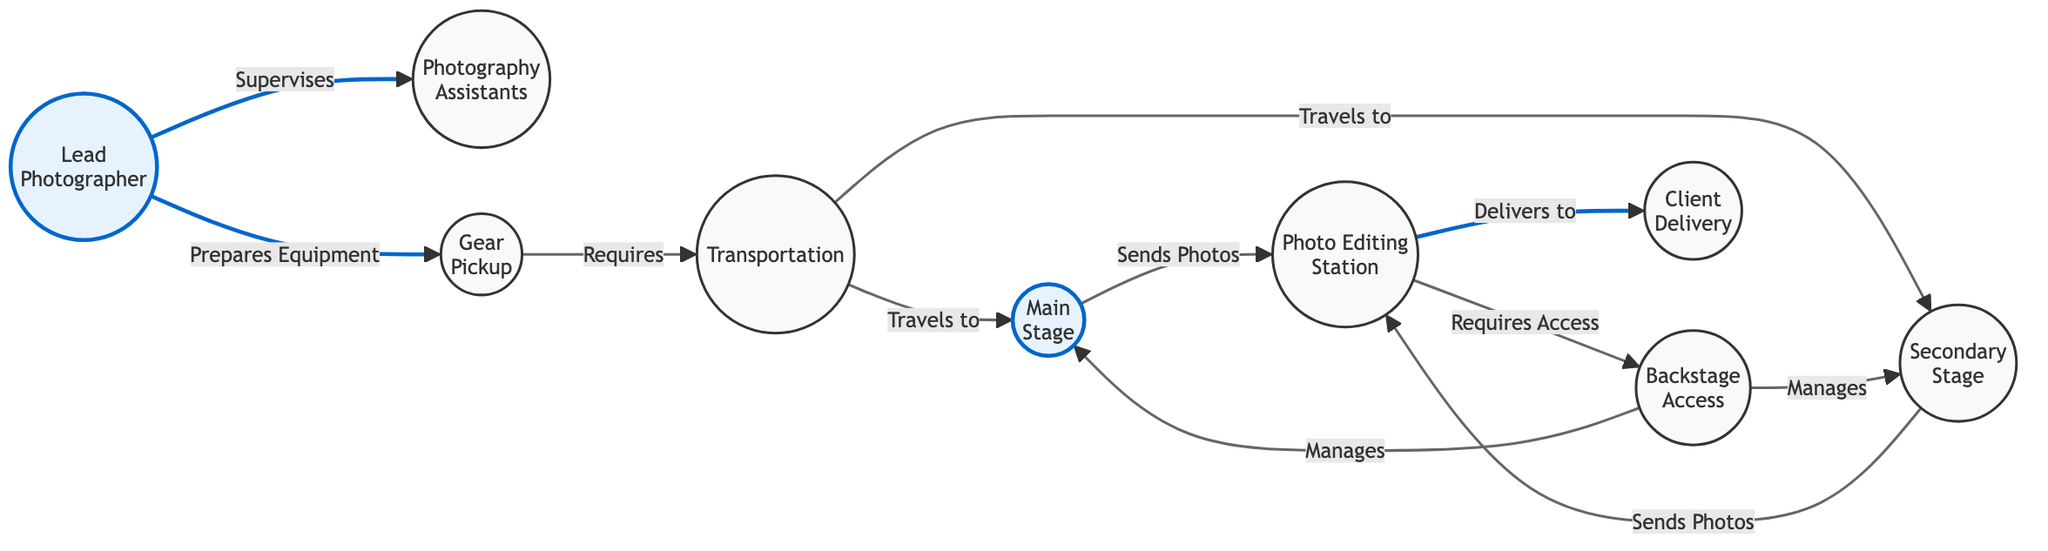What is the relationship between the Lead Photographer and the Photography Assistants? In the diagram, there is a direct edge labeled "Supervises" connecting the Lead Photographer node to the Photography Assistants node. This indicates that the Lead Photographer supervises the assistants.
Answer: Supervises How many nodes are there in the diagram? To find the number of nodes, you can count each unique entity represented in the diagram. There are nine entities: Lead Photographer, Photography Assistants, Gear Pickup, Transportation, Main Stage, Secondary Stage, Photo Editing Station, Backstage Access, Client Delivery.
Answer: Nine What is the target of the "Delivers to" relationship? The "Delivers to" relationship originates from the Editing Station node and points towards the Client Delivery node. This indicates that the editing process results in delivering photos to the festival organizers.
Answer: Client Delivery Which node requires access from the Backstage? The Photo Editing Station node has a direct edge labeled "Requires Access" that points towards the Backstage node. This indicates that the editing station requires backstage access to properly operate or fulfill its tasks.
Answer: Backstage How does the Gear Pickup relate to Transportation? The Gear Pickup node has an edge labeled "Requires" that connects to the Transportation node. This indicates that to fulfill its purpose, the gear pickup requires transportation, likely for the movement of equipment.
Answer: Requires What is the flow of photos from the stages to the editing station? The flow of photos can be traced from two stages: the Main Stage and the Secondary Stage. Both have edges labeled "Sends Photos" directed towards the Editing Station node, indicating that photos from both stages are sent to the editing team.
Answer: Editing Station How many relationships do the Backstage nodes have? The Backstage node has two relationships emanating from it, both labeled "Manages." One relationship points to the Main Stage and the other points to the Secondary Stage. Thus, it is involved with managing both stages.
Answer: Two What entity is responsible for the preparation of equipment? The Lead Photographer node has a direct edge labeled "Prepares Equipment" that connects to the Gear Pickup node. This shows that the preparation of equipment is the responsibility of the Lead Photographer.
Answer: Lead Photographer Which node connects to both the Main Stage and the Photo Editing Station? The Editing Station node connects back to the Main Stage through the "Sends Photos" relationship and has another edge connected to it as it is directed from the Main Stage. Therefore, it connects to both the Main Stage and the Editing Station.
Answer: Editing Station 